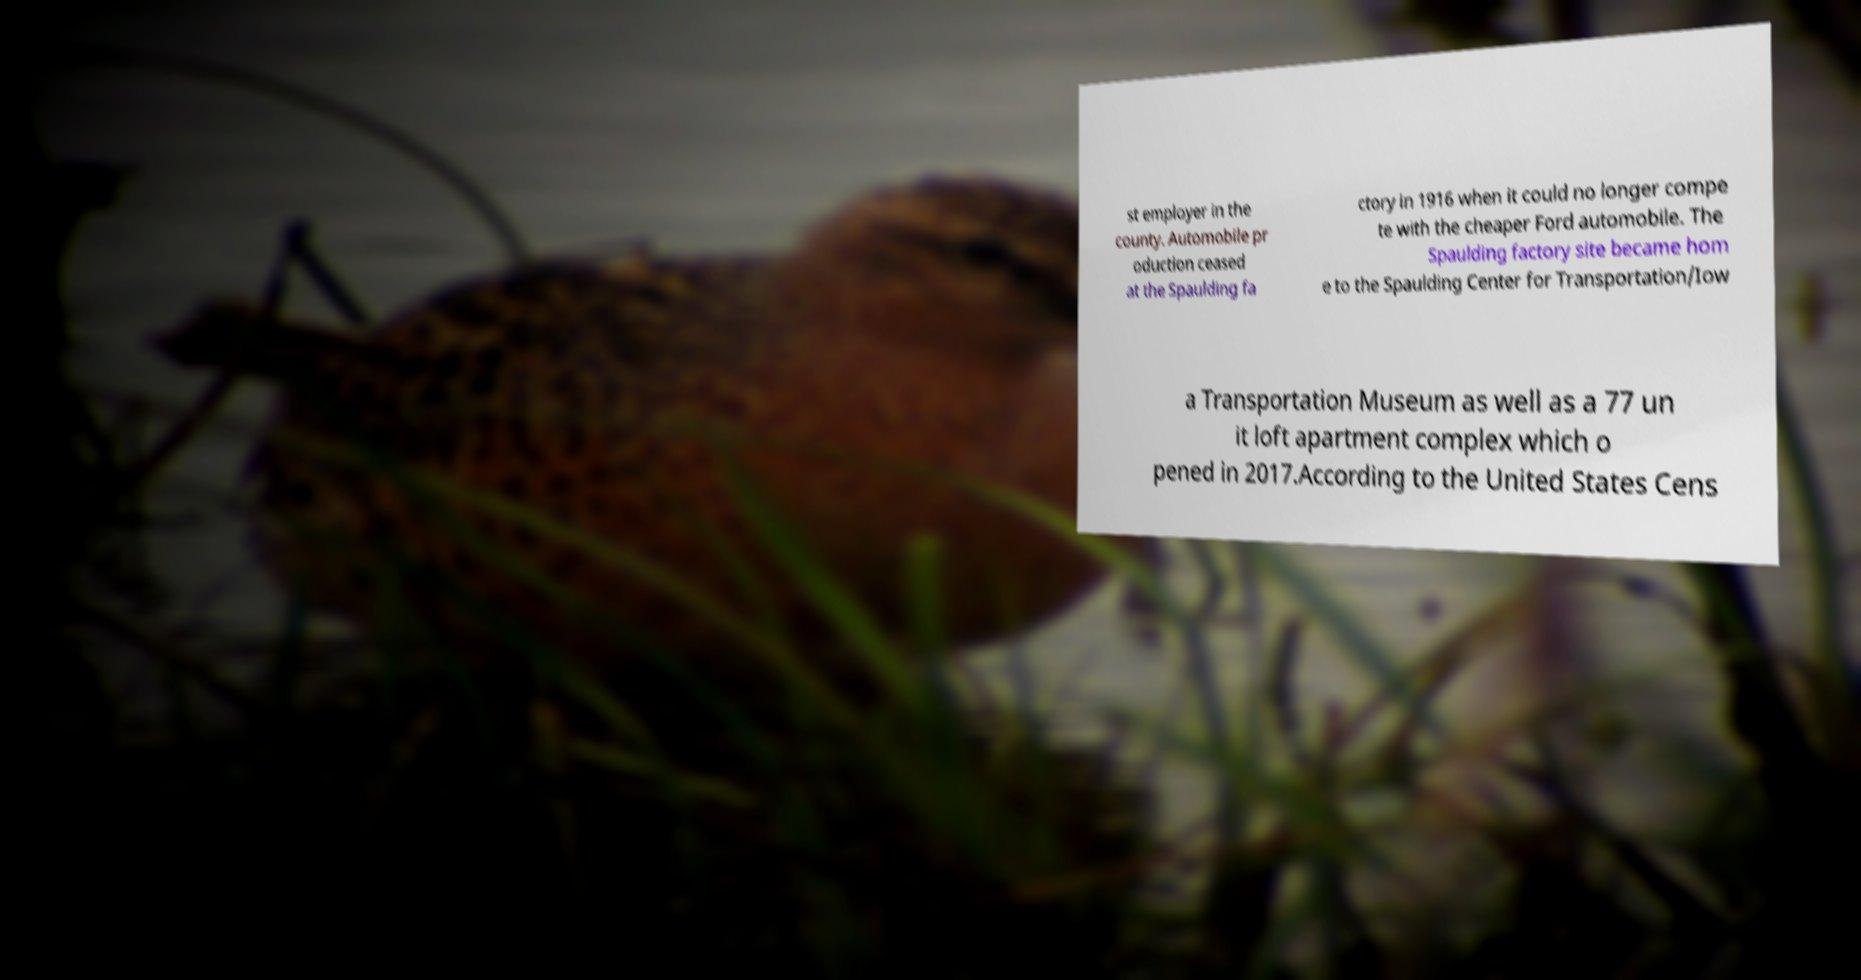For documentation purposes, I need the text within this image transcribed. Could you provide that? st employer in the county. Automobile pr oduction ceased at the Spaulding fa ctory in 1916 when it could no longer compe te with the cheaper Ford automobile. The Spaulding factory site became hom e to the Spaulding Center for Transportation/Iow a Transportation Museum as well as a 77 un it loft apartment complex which o pened in 2017.According to the United States Cens 